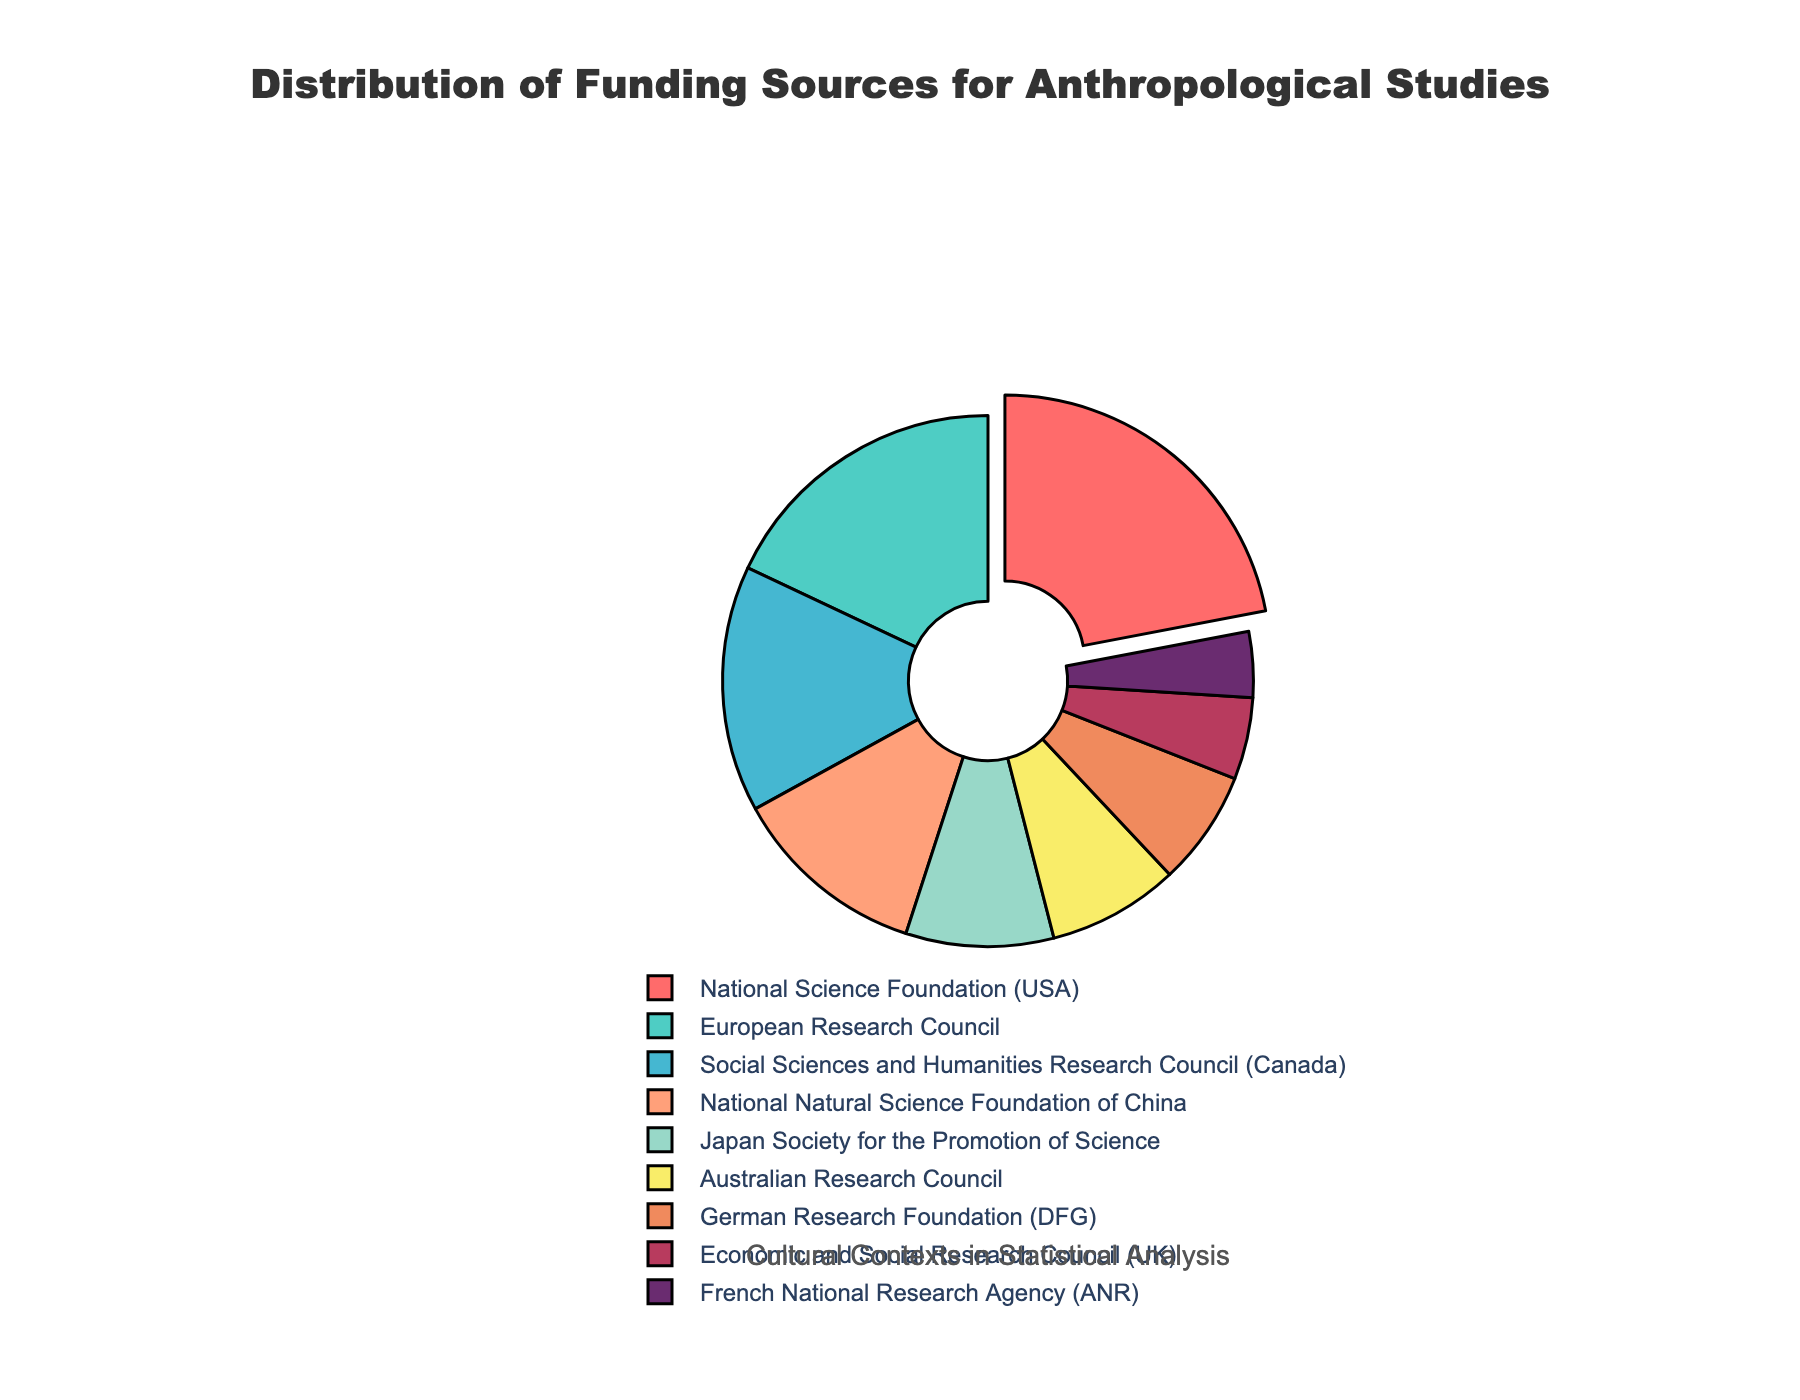What is the most significant funding source for anthropological studies according to the chart? The chart shows the percentage of various funding sources. The National Science Foundation (USA) section is pulled out and has the highest percentage.
Answer: National Science Foundation (USA) Which funding source contributes more, the Japanese or the Australian research councils? By comparing the percentages, the Japan Society for the Promotion of Science contributes 9%, whereas the Australian Research Council contributes 8%.
Answer: Japan Society for the Promotion of Science What is the combined percentage of the National Natural Science Foundation of China and the German Research Foundation (DFG)? The chart shows that the National Natural Science Foundation of China has 12% and the German Research Foundation (DFG) has 7%. Adding these gives 12% + 7% = 19%.
Answer: 19% How much more does the European Research Council contribute compared to the Economic and Social Research Council (UK)? The European Research Council contributes 18%, while the Economic and Social Research Council (UK) contributes 5%. The difference is 18% - 5% = 13%.
Answer: 13% Which organizations contribute less than 10% and more than 5%? From the chart: the Japan Society for the Promotion of Science (9%), Australian Research Council (8%), and German Research Foundation (DFG) (7%) fall into the range of less than 10% but more than 5%.
Answer: Japan Society for the Promotion of Science, Australian Research Council, German Research Foundation (DFG) What is the average contribution percentage of the top three funding sources? The top three funding sources are National Science Foundation (USA) with 22%, European Research Council with 18%, and the Social Sciences and Humanities Research Council (Canada) with 15%. The average is (22% + 18% + 15%)/3 = 55%/3 ≈ 18.33%.
Answer: 18.33% 